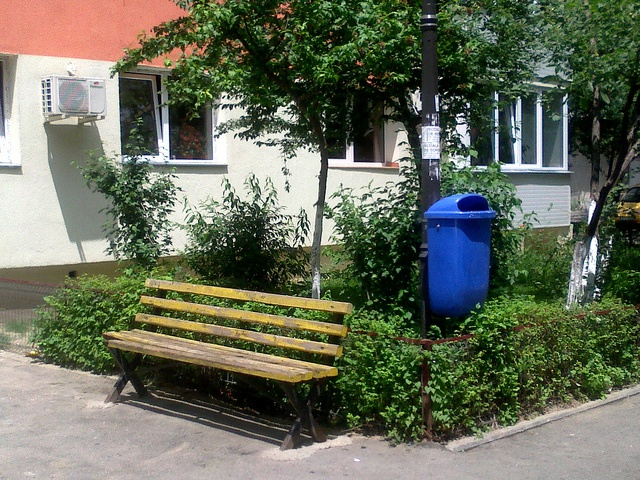Describe the objects in this image and their specific colors. I can see bench in salmon, black, tan, and darkgreen tones and car in salmon, black, olive, gray, and tan tones in this image. 